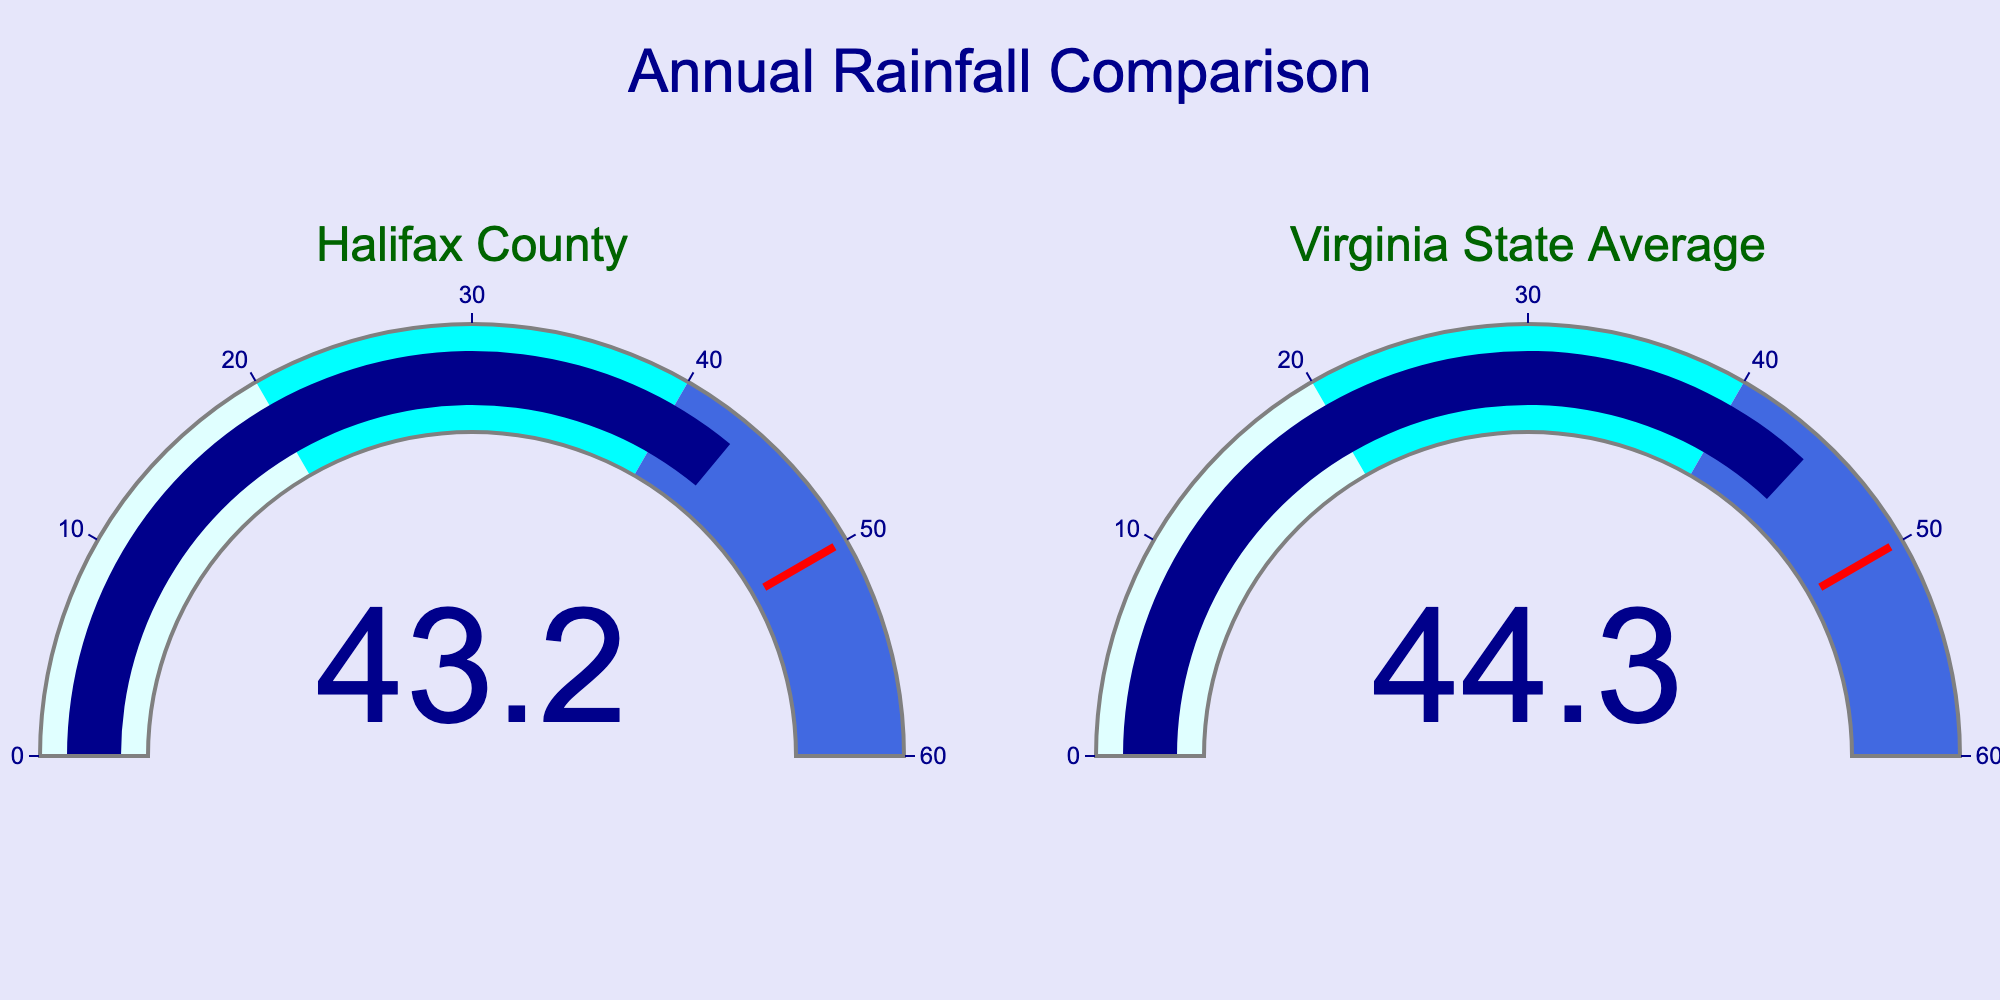What is the title of the figure? The title of the figure is at the top center and reads "Annual Rainfall Comparison".
Answer: Annual Rainfall Comparison How many locations are compared in the figure? The figure contains two gauge charts, one for Halifax County and one for the Virginia State Average.
Answer: Two What is the annual rainfall in Halifax County? The annual rainfall in Halifax County is shown directly on its corresponding gauge chart, which reads 43.2 inches.
Answer: 43.2 inches What is the annual rainfall in Virginia State Average? The annual rainfall for the Virginia State Average is displayed on its gauge chart, which reads 44.3 inches.
Answer: 44.3 inches Which location has a higher annual rainfall? By comparing the values on the gauge charts, we see that Virginia State Average (44.3 inches) has a higher annual rainfall than Halifax County (43.2 inches).
Answer: Virginia State Average By how much does the annual rainfall in Virginia State Average exceed that of Halifax County? Subtract the rainfall in Halifax County from the rainfall in Virginia State Average: 44.3 inches - 43.2 inches = 1.1 inches.
Answer: 1.1 inches What color represents the gauge bars in both charts? Both gauge bars are colored dark blue.
Answer: Dark blue What is the range of the gauges? The range of the gauges, indicated by the axis, goes from 0 to 60 inches.
Answer: 0 to 60 inches What are the three colored steps in the gauges, and what ranges do they represent? The gauge background is split into three color steps: light cyan for 0-20 inches, cyan for 20-40 inches, and royal blue for 40-60 inches.
Answer: Light cyan (0-20), cyan (20-40), royal blue (40-60) Is the annual rainfall in Halifax County above or below the 50-inch threshold shown on the gauge? The annual rainfall in Halifax County is 43.2 inches, which is below the 50-inch threshold marked by the red line on the gauge.
Answer: Below 